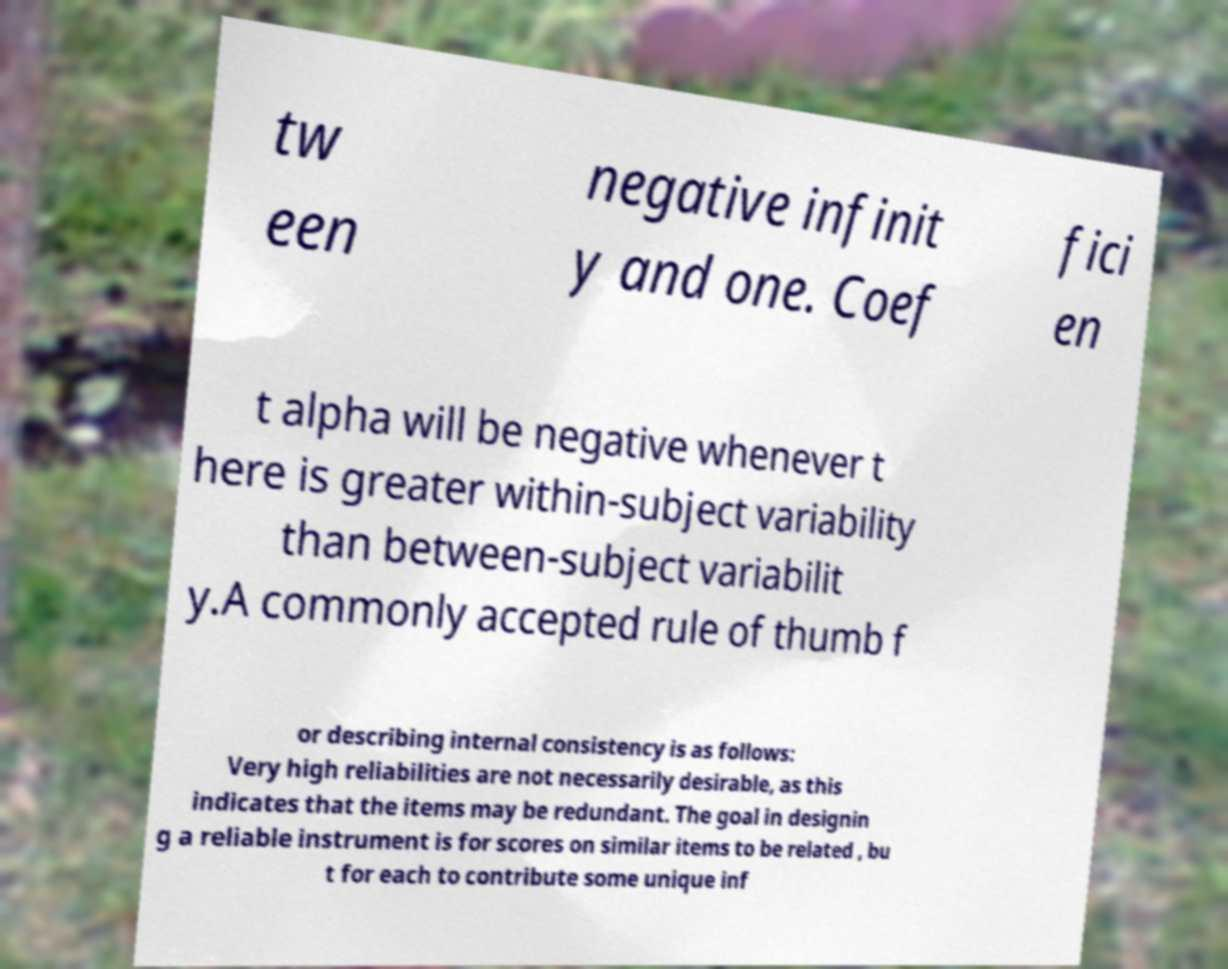What messages or text are displayed in this image? I need them in a readable, typed format. tw een negative infinit y and one. Coef fici en t alpha will be negative whenever t here is greater within-subject variability than between-subject variabilit y.A commonly accepted rule of thumb f or describing internal consistency is as follows: Very high reliabilities are not necessarily desirable, as this indicates that the items may be redundant. The goal in designin g a reliable instrument is for scores on similar items to be related , bu t for each to contribute some unique inf 